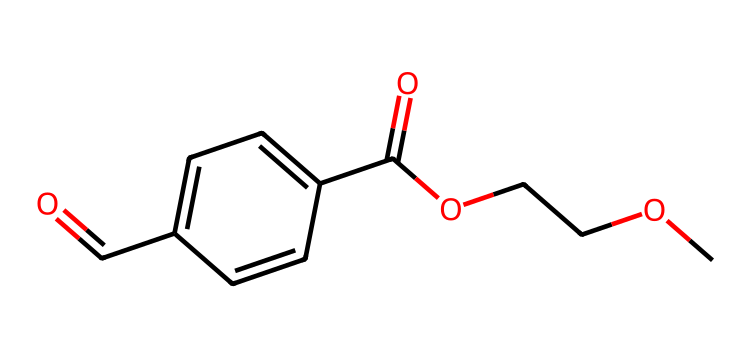What are the main functional groups present in this chemical? The structure contains a carboxylic acid group (-COOH) and an ether group (-O-), which can be identified by the presence of the carbonyl and the oxygen in the carbon chain.
Answer: carboxylic acid and ether How many carbon atoms are in this chemical? Counting the carbon atoms from the SMILES representation indicates there are 9 carbon atoms within the entire structure, including those in the functional groups.
Answer: 9 What type of polymer does this chemical represent? Given the presence of ester functionalities and the structure's connectivity, this chemical is indicative of a polyester, which forms through the reaction of alcohols and acids.
Answer: polyester How many oxygen atoms are present in this chemical? By analyzing the SMILES representation, we can count there are 4 oxygen atoms present in the chemical structure, pertaining to the functional groups.
Answer: 4 What is the significance of the carbonyl group in this chemical? The carbonyl group (C=O) plays a critical role in defining the reactivity and properties of this polymer, contributing to its ability to undergo various chemical reactions and influencing its physical characteristics.
Answer: reactivity and properties 